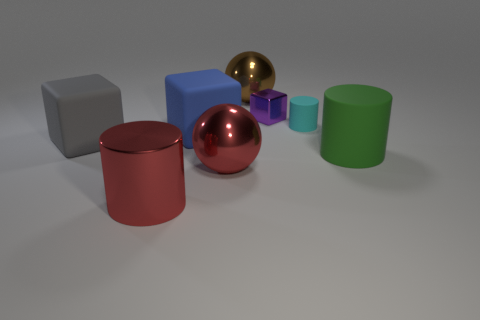Add 1 large gray rubber things. How many objects exist? 9 Subtract all small cubes. How many cubes are left? 2 Subtract all blocks. How many objects are left? 5 Add 1 large blue things. How many large blue things exist? 2 Subtract 0 purple cylinders. How many objects are left? 8 Subtract all small rubber objects. Subtract all rubber objects. How many objects are left? 3 Add 1 big matte cubes. How many big matte cubes are left? 3 